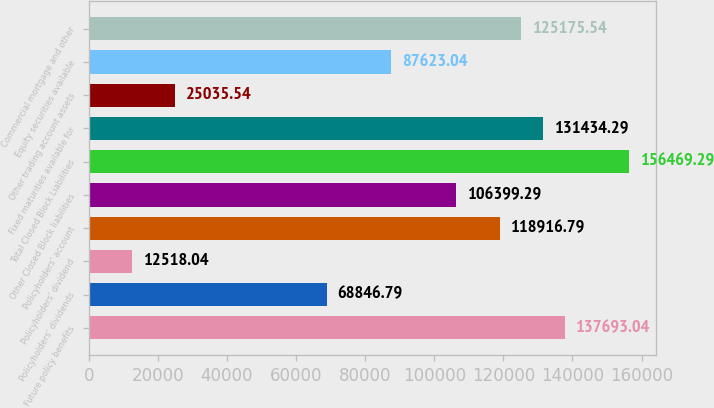<chart> <loc_0><loc_0><loc_500><loc_500><bar_chart><fcel>Future policy benefits<fcel>Policyholders' dividends<fcel>Policyholders' dividend<fcel>Policyholders' account<fcel>Other Closed Block liabilities<fcel>Total Closed Block Liabilities<fcel>Fixed maturities available for<fcel>Other trading account assets<fcel>Equity securities available<fcel>Commercial mortgage and other<nl><fcel>137693<fcel>68846.8<fcel>12518<fcel>118917<fcel>106399<fcel>156469<fcel>131434<fcel>25035.5<fcel>87623<fcel>125176<nl></chart> 